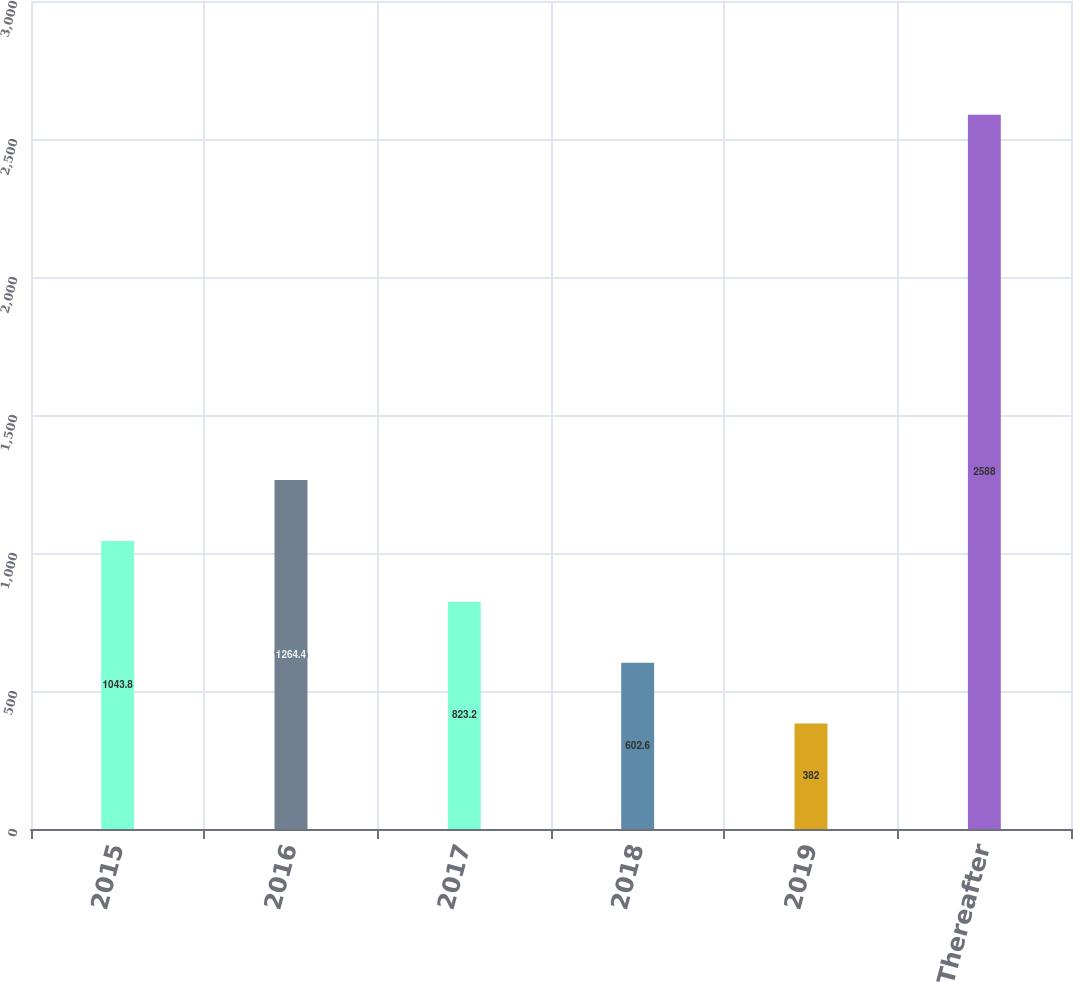Convert chart to OTSL. <chart><loc_0><loc_0><loc_500><loc_500><bar_chart><fcel>2015<fcel>2016<fcel>2017<fcel>2018<fcel>2019<fcel>Thereafter<nl><fcel>1043.8<fcel>1264.4<fcel>823.2<fcel>602.6<fcel>382<fcel>2588<nl></chart> 